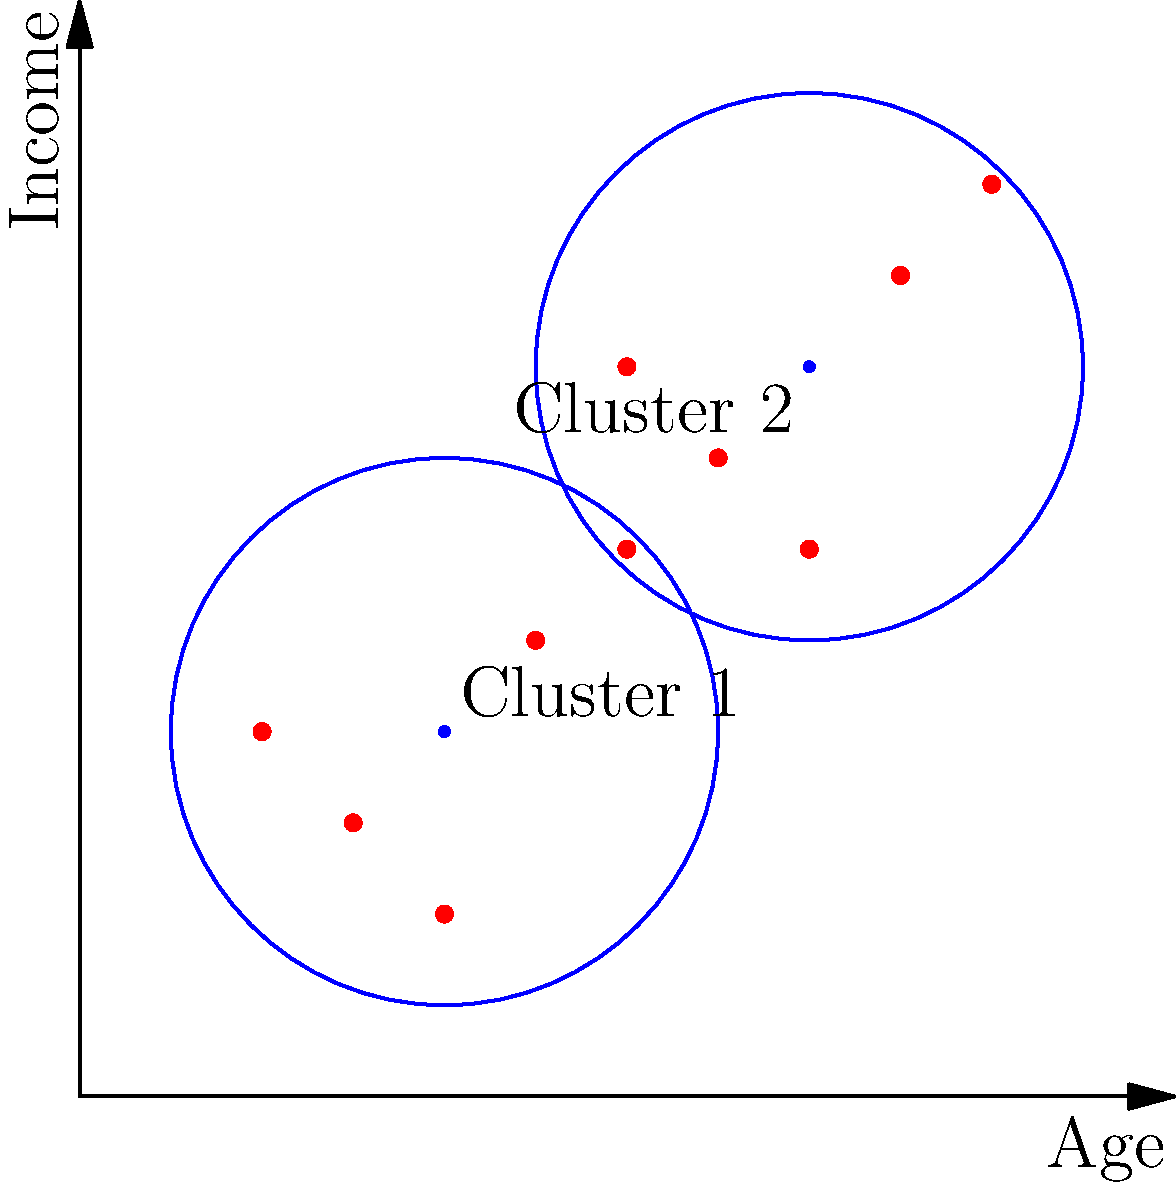Based on the 2D plot showing veteran demographics clustered by age and income, which cluster would you prioritize for affordable housing services, and why? To answer this question, we need to analyze the two clusters shown in the plot:

1. Identify the clusters:
   - Cluster 1: centered around (2, 2) on the age-income plane
   - Cluster 2: centered around (4, 4) on the age-income plane

2. Interpret the axes:
   - X-axis represents age (increasing from left to right)
   - Y-axis represents income (increasing from bottom to top)

3. Analyze Cluster 1:
   - Lower age range
   - Lower income range
   - More densely packed (tighter cluster)

4. Analyze Cluster 2:
   - Higher age range
   - Higher income range
   - More spread out (looser cluster)

5. Consider the needs for affordable housing:
   - Lower income groups typically have a higher need for affordable housing
   - Younger veterans may have less established careers and savings

6. Make a decision:
   - Cluster 1 represents younger veterans with lower incomes
   - This group is likely to have a higher need for affordable housing services

Therefore, as a property manager overseeing affordable homes for veterans, prioritizing Cluster 1 for housing services would be more beneficial. This group is more likely to need and qualify for affordable housing due to their lower income levels and younger age.
Answer: Cluster 1, due to lower income and younger age demographics. 